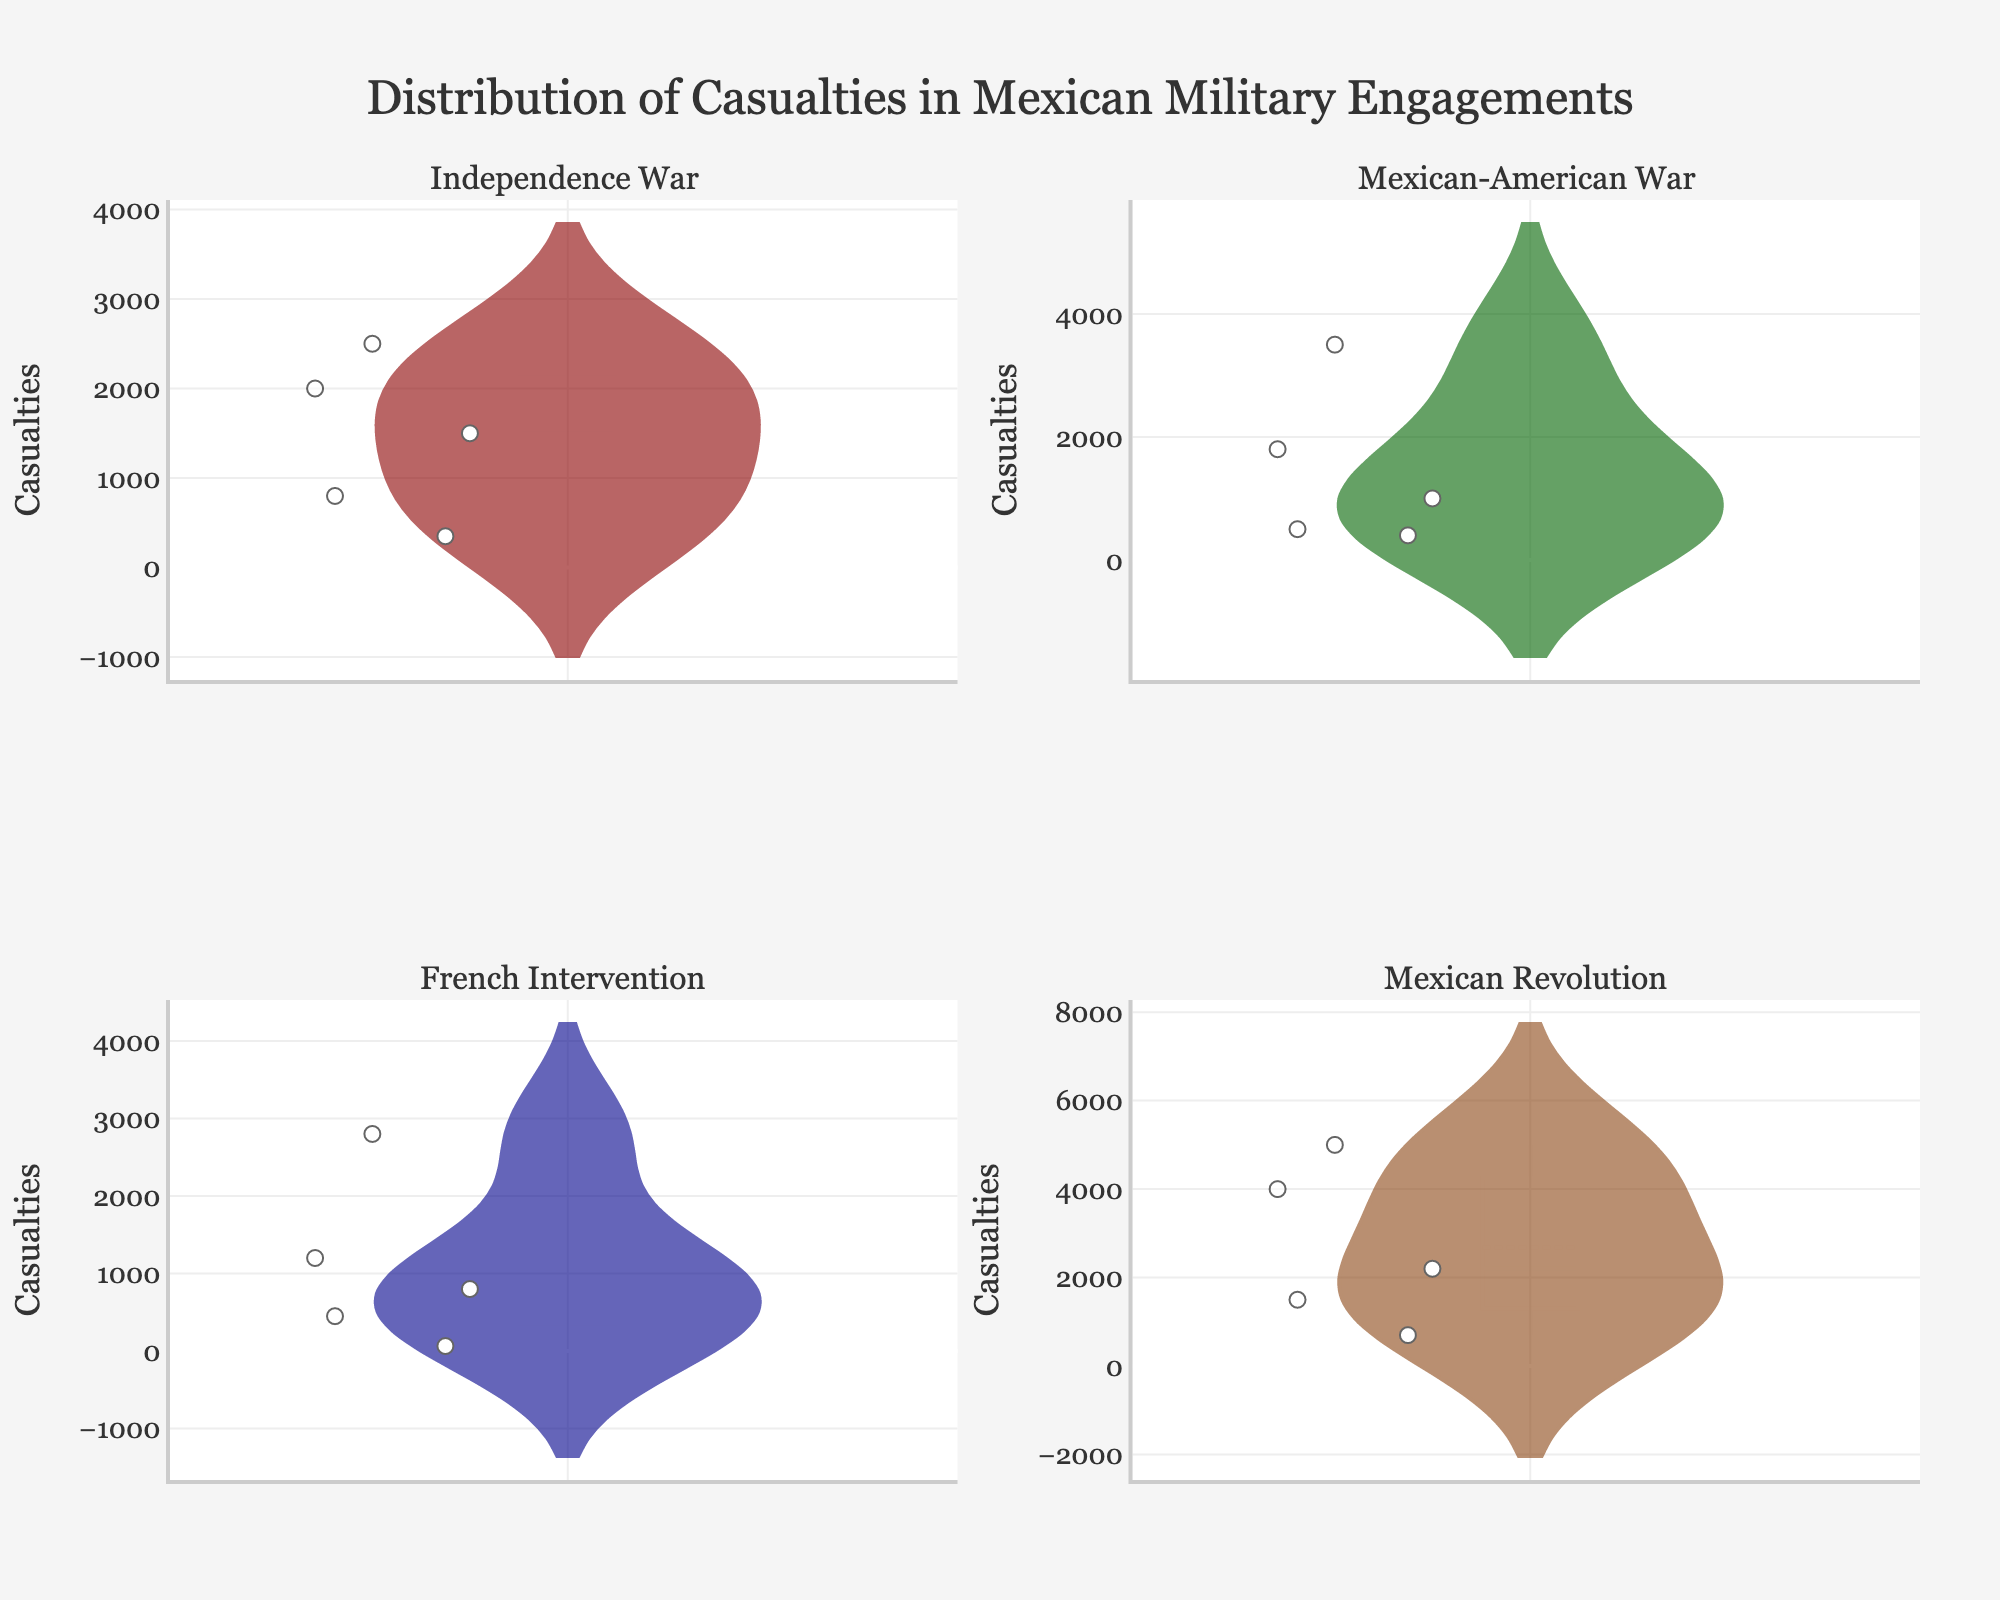What is the title of the plot? The title is usually found at the top of the plot. In this case, it reads, "Distribution of Casualties in Mexican Military Engagements".
Answer: Distribution of Casualties in Mexican Military Engagements Which war type has the highest median casualties? To find the war type with the highest median, we look at the central horizontal line in each violin plot. The "Mexican Revolution" subplot shows the highest median.
Answer: Mexican Revolution How many casualties occurred during the Battle of Zacatecas? Hovering over the points within the "Mexican Revolution" subplot reveals specific engagement names and casualty numbers. The Battle of Zacatecas shows 5000 casualties.
Answer: 5000 Which war has the engagement with the highest number of casualties? By looking at the highest points in each subplot, we see that the "Mexican Revolution" has the single engagement with the highest number of casualties (Battle of Zacatecas, 5000 casualties).
Answer: Mexican Revolution Which war type shows the most variation in casualties? Variation can be observed through the spread of each violin plot. The "Mexican Revolution" has the widest spread, indicating the most variation in casualties.
Answer: Mexican Revolution What color represents the Mexican-American War in the plot? Each subplot is filled with a distinct color. The subplot "Mexican-American War" is filled with dark green color.
Answer: Dark green Which engagement under the French Intervention resulted in the fewest casualties? Hovering over the points in the "French Intervention" subplot, we see that the Battle of Camerone had the fewest casualties, with only 65.
Answer: Battle of Camerone Are there more engagements with casualties above 2000 in the Independence War or the Mexican-American War? Observing the points and their positions above the 2000 mark in each subplot, the Independence War has one engagement above 2000 (Siege of Cuautla), while the Mexican-American War has one (Battle of Buena Vista). Thus, they are equal.
Answer: Equal Is the mean line visible in each subplot? The mean line, if present, is a horizontal line across each violin plot. Yes, each subplot shows a mean line; this indicates that they are visible in all subplots.
Answer: Yes Which subplot contains an engagement with exactly 1800 casualties? By hovering over the points in each subplot, we see that the "Mexican-American War" subplot contains an engagement (Battle of Monterrey) with exactly 1800 casualties.
Answer: Mexican-American War 